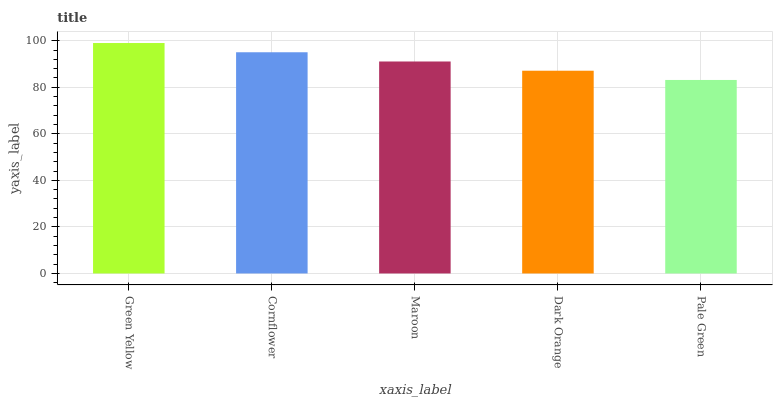Is Pale Green the minimum?
Answer yes or no. Yes. Is Green Yellow the maximum?
Answer yes or no. Yes. Is Cornflower the minimum?
Answer yes or no. No. Is Cornflower the maximum?
Answer yes or no. No. Is Green Yellow greater than Cornflower?
Answer yes or no. Yes. Is Cornflower less than Green Yellow?
Answer yes or no. Yes. Is Cornflower greater than Green Yellow?
Answer yes or no. No. Is Green Yellow less than Cornflower?
Answer yes or no. No. Is Maroon the high median?
Answer yes or no. Yes. Is Maroon the low median?
Answer yes or no. Yes. Is Pale Green the high median?
Answer yes or no. No. Is Pale Green the low median?
Answer yes or no. No. 